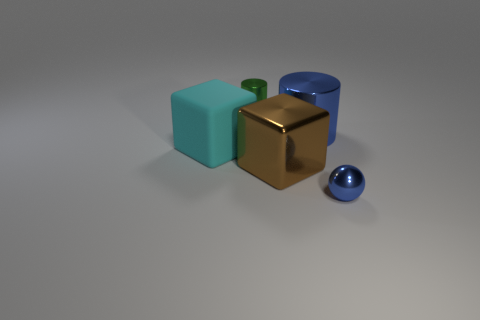Add 4 rubber blocks. How many objects exist? 9 Subtract all cubes. How many objects are left? 3 Add 4 tiny cyan rubber cylinders. How many tiny cyan rubber cylinders exist? 4 Subtract 1 blue cylinders. How many objects are left? 4 Subtract all purple rubber cylinders. Subtract all large blue shiny things. How many objects are left? 4 Add 1 metallic objects. How many metallic objects are left? 5 